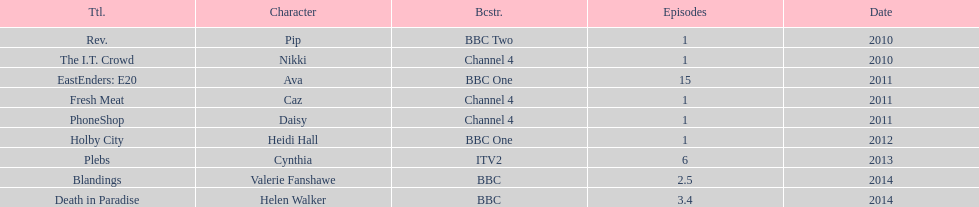Blandings and death in paradise were broadcasted on which channel? BBC. Parse the table in full. {'header': ['Ttl.', 'Character', 'Bcstr.', 'Episodes', 'Date'], 'rows': [['Rev.', 'Pip', 'BBC Two', '1', '2010'], ['The I.T. Crowd', 'Nikki', 'Channel 4', '1', '2010'], ['EastEnders: E20', 'Ava', 'BBC One', '15', '2011'], ['Fresh Meat', 'Caz', 'Channel 4', '1', '2011'], ['PhoneShop', 'Daisy', 'Channel 4', '1', '2011'], ['Holby City', 'Heidi Hall', 'BBC One', '1', '2012'], ['Plebs', 'Cynthia', 'ITV2', '6', '2013'], ['Blandings', 'Valerie Fanshawe', 'BBC', '2.5', '2014'], ['Death in Paradise', 'Helen Walker', 'BBC', '3.4', '2014']]} 